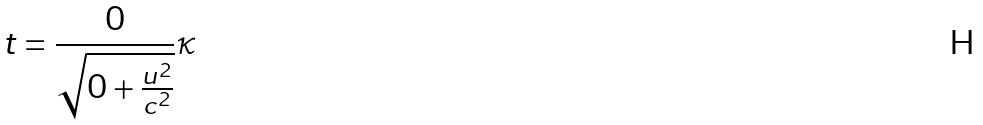<formula> <loc_0><loc_0><loc_500><loc_500>t = \frac { 0 } { \sqrt { 0 + \frac { u ^ { 2 } } { c ^ { 2 } } } } \kappa</formula> 